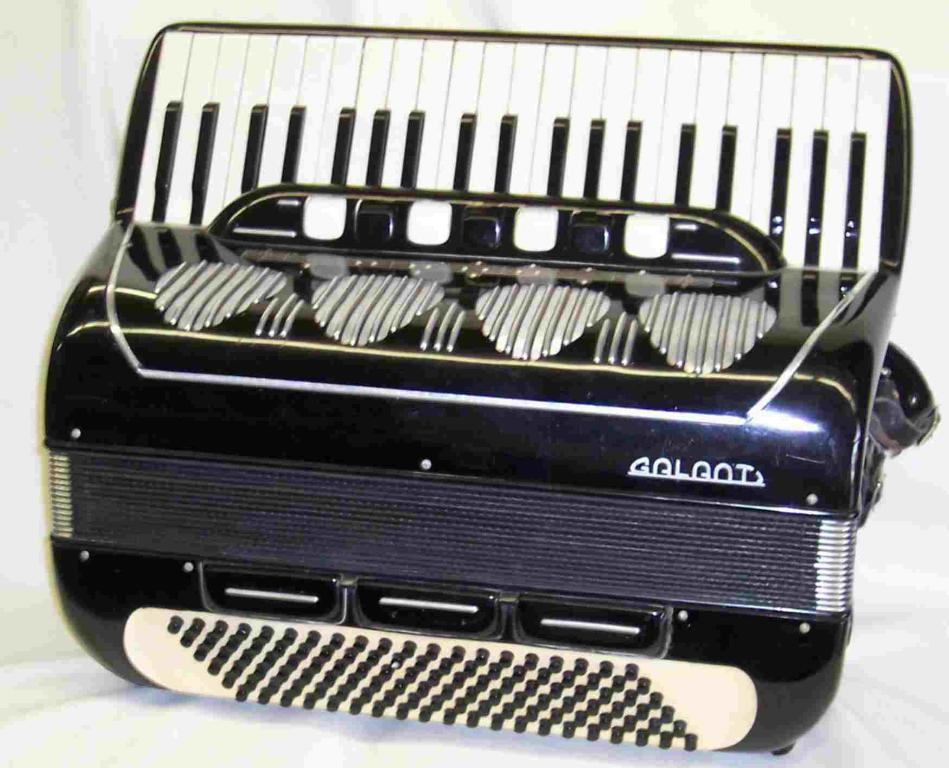What type of device is visible in the image? There is a Garmin device in the image. Where is the Garmin device located? The Garmin device is placed on a table. What type of berry is being weighed on the Garmin device in the image? There is no berry present in the image, and the Garmin device is not being used for weighing anything. 